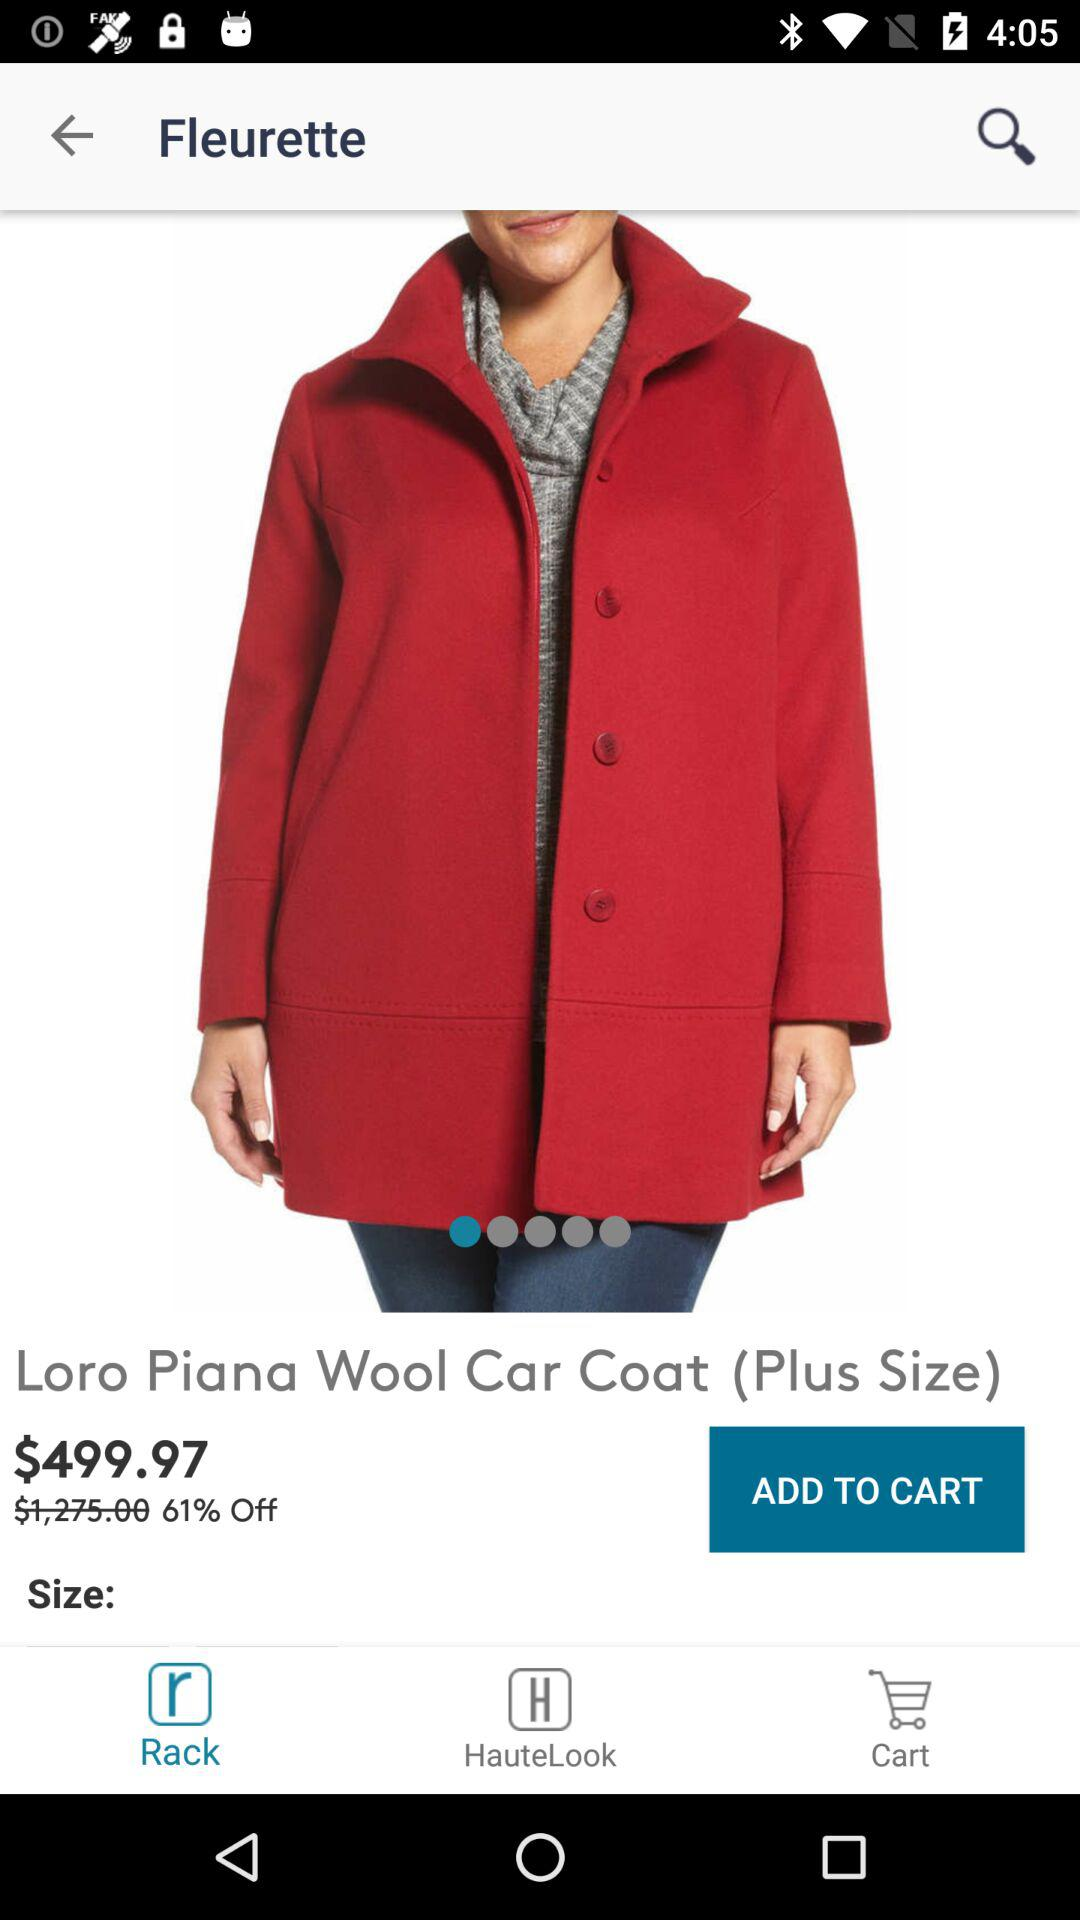What is the percentage off the original price?
Answer the question using a single word or phrase. 61% 